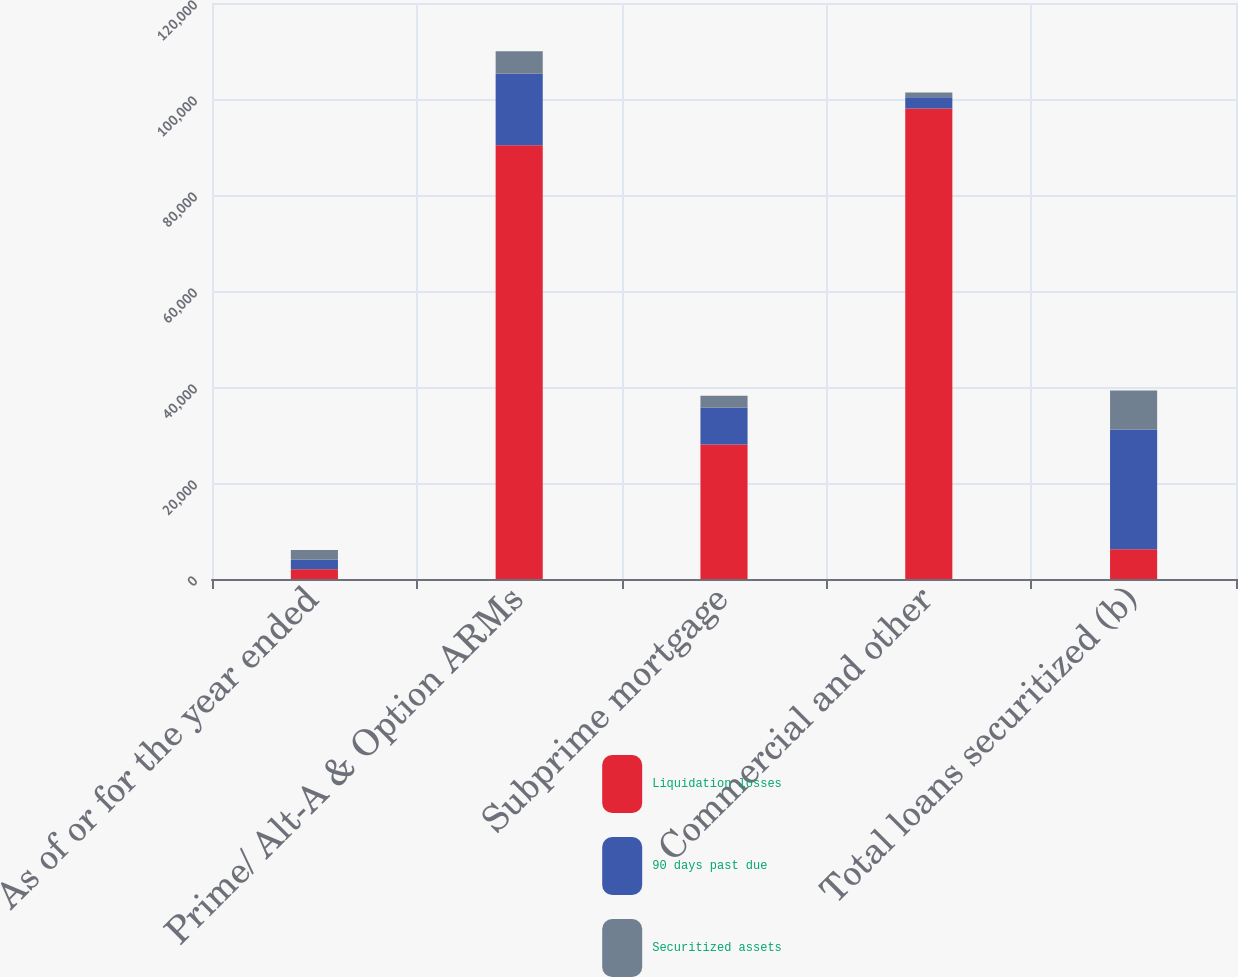<chart> <loc_0><loc_0><loc_500><loc_500><stacked_bar_chart><ecel><fcel>As of or for the year ended<fcel>Prime/ Alt-A & Option ARMs<fcel>Subprime mortgage<fcel>Commercial and other<fcel>Total loans securitized (b)<nl><fcel>Liquidation losses<fcel>2013<fcel>90381<fcel>28008<fcel>98018<fcel>6207<nl><fcel>90 days past due<fcel>2013<fcel>14882<fcel>7726<fcel>2350<fcel>24958<nl><fcel>Securitized assets<fcel>2013<fcel>4688<fcel>2420<fcel>1003<fcel>8111<nl></chart> 